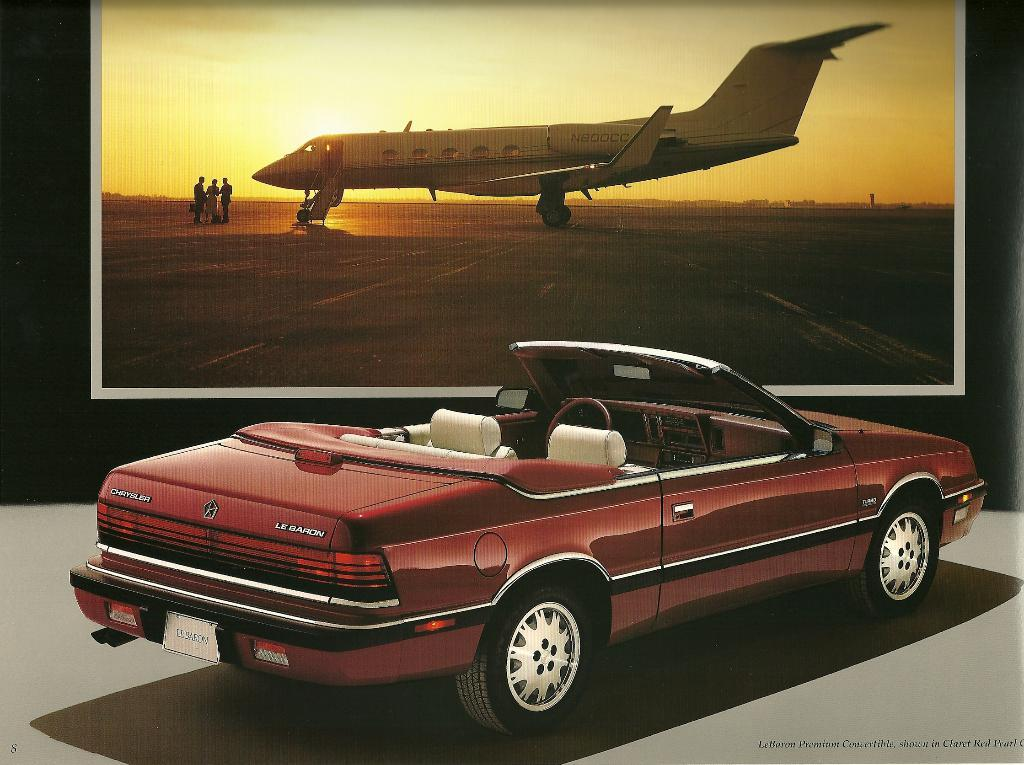<image>
Offer a succinct explanation of the picture presented. A CONVERTIBLE RED CRYSTLER LE BARON IN FRONT OF A PICTURE OF A SMALL AIRPLANE 